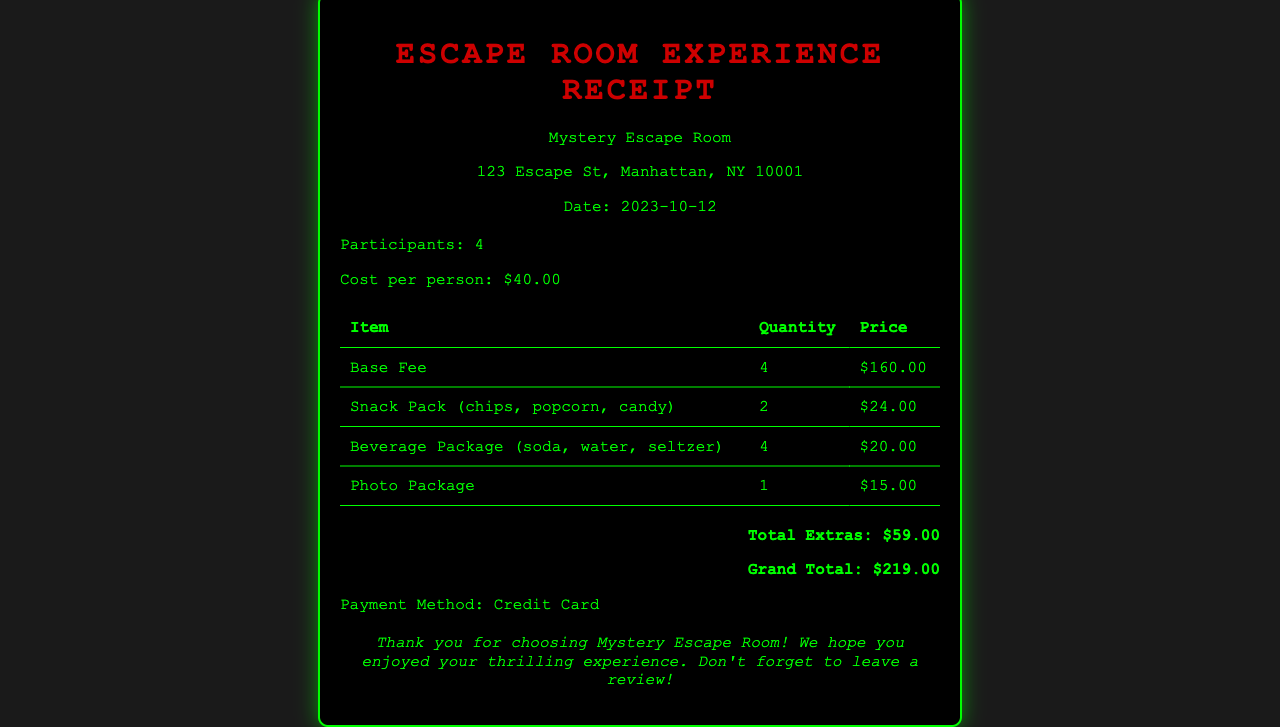what is the name of the escape room? The name of the escape room is listed in the header section of the document.
Answer: Mystery Escape Room what is the street address of the escape room? The street address of the escape room is provided under the name in the header section.
Answer: 123 Escape St, Manhattan, NY 10001 how many participants were there? The number of participants is mentioned in the details section of the document.
Answer: 4 what is the total cost for all participants? The grand total at the bottom summarizes the total cost incurred for the escape room experience.
Answer: $219.00 how much was paid for the Beverage Package? The price of the Beverage Package is given in the itemized table.
Answer: $20.00 what is the quantity of Snack Packs ordered? The quantity of Snack Packs is specified in the itemized table of extras.
Answer: 2 what was the price for one participant? The cost per person is stated in the details section.
Answer: $40.00 how much did the Photo Package cost? The cost for the Photo Package is recorded in the table of items.
Answer: $15.00 what extras were included in the Snack Pack? The contents of the Snack Pack are described in the itemized table under the Snack Pack entry.
Answer: chips, popcorn, candy 